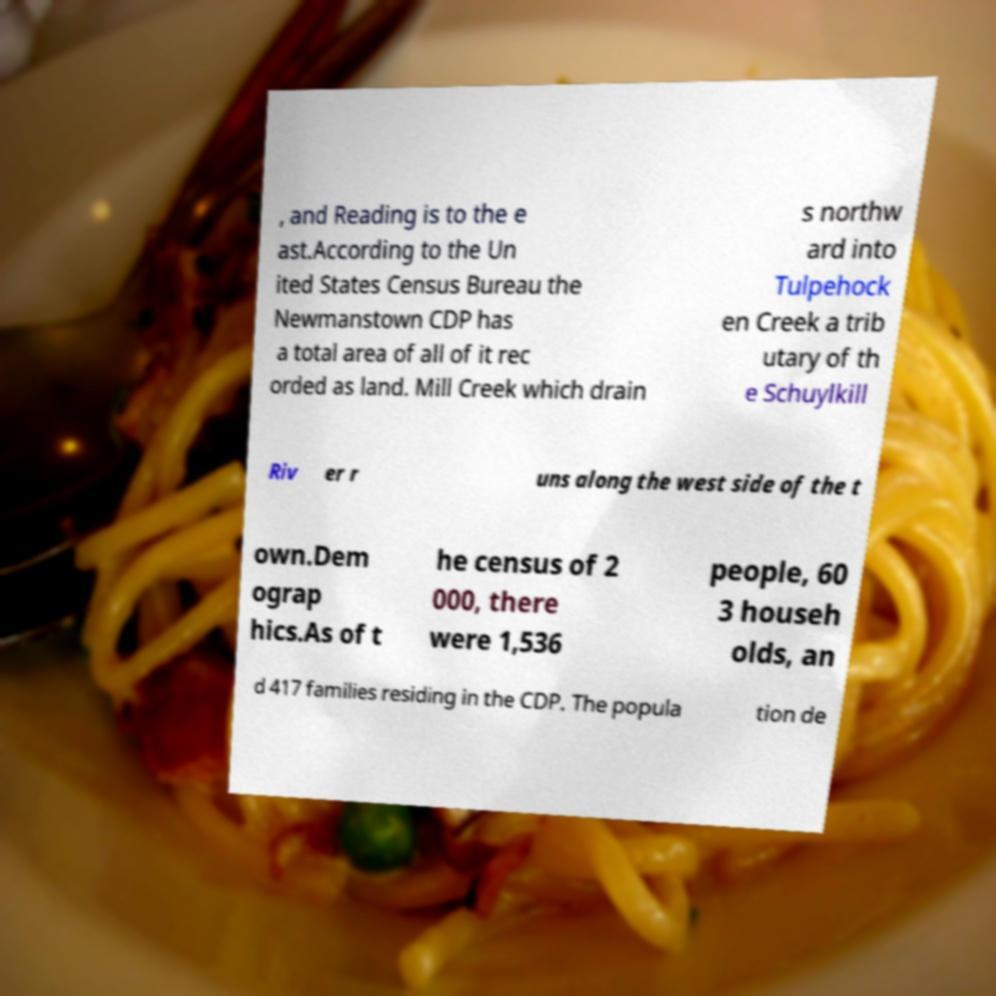Please read and relay the text visible in this image. What does it say? , and Reading is to the e ast.According to the Un ited States Census Bureau the Newmanstown CDP has a total area of all of it rec orded as land. Mill Creek which drain s northw ard into Tulpehock en Creek a trib utary of th e Schuylkill Riv er r uns along the west side of the t own.Dem ograp hics.As of t he census of 2 000, there were 1,536 people, 60 3 househ olds, an d 417 families residing in the CDP. The popula tion de 